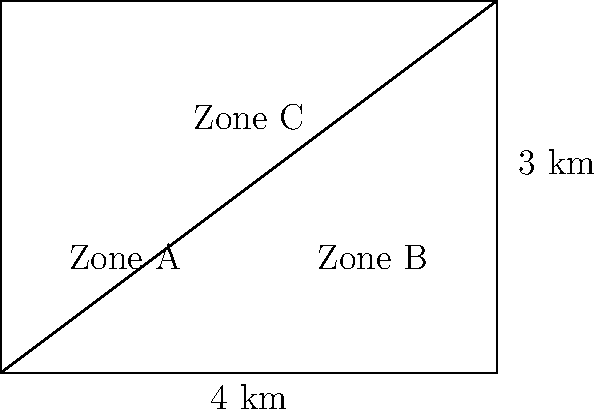A city is divided into three socioeconomic zones as shown in the diagram. Zone A and Zone B are triangular, while Zone C is a rectangle. The entire area is 4 km wide and 3 km long. If the dividing line between Zone A and Zone B passes through the center point of the rectangle, compare the areas of the three zones to assess the equality of public service distribution. Which zone has the largest area, and by what percentage is it larger than the smallest zone? Let's approach this step-by-step:

1) First, calculate the total area of the rectangle:
   Area of rectangle = $4 \text{ km} \times 3 \text{ km} = 12 \text{ km}^2$

2) The dividing line passes through the center, so Zone A and Zone B are congruent right triangles. Their areas will be equal.

3) Calculate the area of Zone A (or B):
   Area of triangle = $\frac{1}{2} \times \text{base} \times \text{height}$
   $= \frac{1}{2} \times 2 \text{ km} \times 3 \text{ km} = 3 \text{ km}^2$

4) Zone C is the remaining area:
   Area of Zone C = Total area - (Area of Zone A + Area of Zone B)
   $= 12 \text{ km}^2 - (3 \text{ km}^2 + 3 \text{ km}^2) = 6 \text{ km}^2$

5) Zone C has the largest area at $6 \text{ km}^2$, while Zone A and Zone B each have $3 \text{ km}^2$.

6) To calculate the percentage difference:
   Percentage difference = $\frac{\text{Larger area} - \text{Smaller area}}{\text{Smaller area}} \times 100\%$
   $= \frac{6 \text{ km}^2 - 3 \text{ km}^2}{3 \text{ km}^2} \times 100\% = 100\%$

Therefore, Zone C (the largest) is 100% larger than Zone A or B (the smallest).
Answer: Zone C; 100% larger 